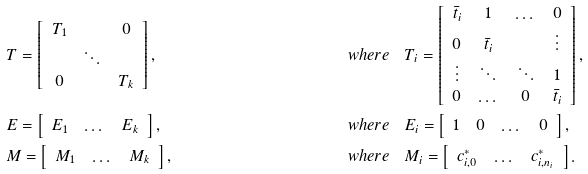Convert formula to latex. <formula><loc_0><loc_0><loc_500><loc_500>& T = \left [ \begin{array} { c c c } T _ { 1 } & & 0 \\ & \ddots & \\ 0 & & T _ { k } \end{array} \right ] , & \quad w h e r e \quad & T _ { i } = \left [ \begin{array} { c c c c } \bar { t } _ { i } & 1 & \dots & 0 \\ 0 & \bar { t } _ { i } & & \vdots \\ \vdots & \ddots & \ddots & 1 \\ 0 & \dots & 0 & \bar { t } _ { i } \end{array} \right ] , \\ & E = \left [ \begin{array} { c c c } E _ { 1 } & \dots & E _ { k } \end{array} \right ] , & \quad w h e r e \quad & E _ { i } = \left [ \begin{array} { c c c c } 1 & 0 & \dots & 0 \end{array} \right ] , \\ & M = \left [ \begin{array} { c c c } M _ { 1 } & \dots & M _ { k } \end{array} \right ] , & \quad w h e r e \quad & M _ { i } = \left [ \begin{array} { c c c } { c } _ { i , 0 } ^ { * } & \dots & { c } _ { i , n _ { i } } ^ { * } \end{array} \right ] .</formula> 